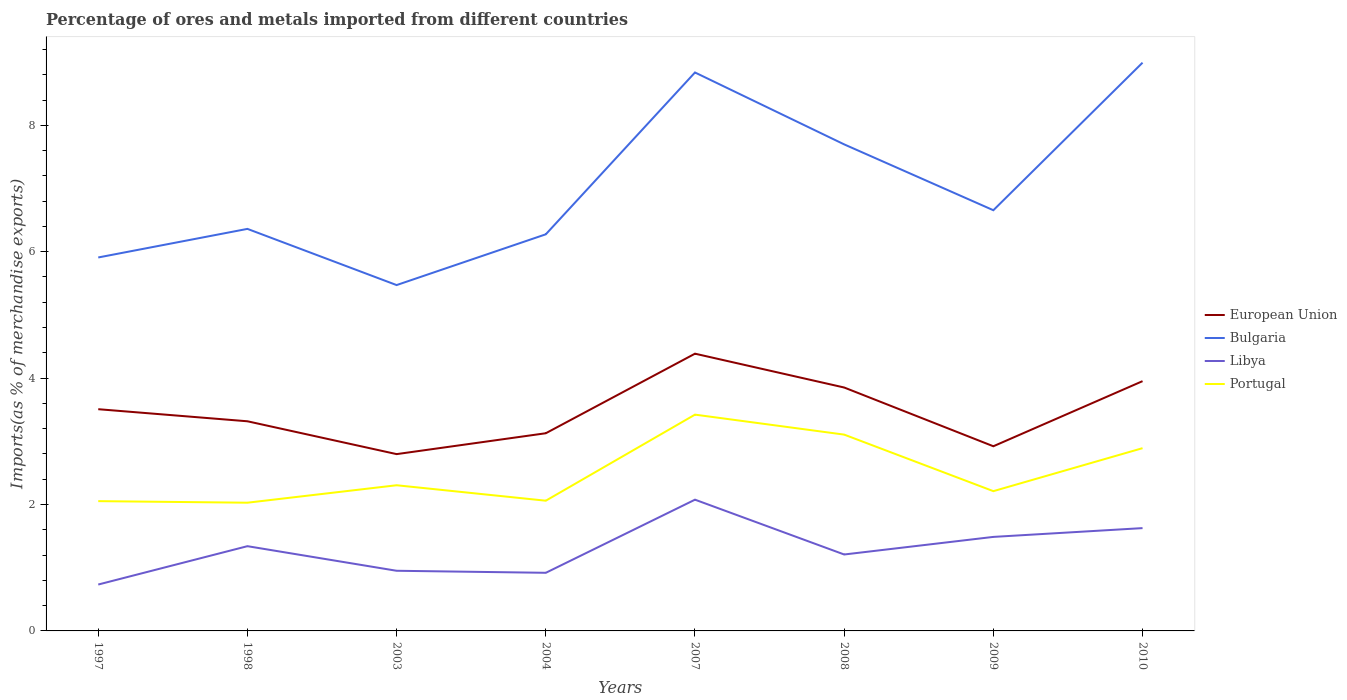Is the number of lines equal to the number of legend labels?
Offer a very short reply. Yes. Across all years, what is the maximum percentage of imports to different countries in Bulgaria?
Ensure brevity in your answer.  5.47. What is the total percentage of imports to different countries in European Union in the graph?
Make the answer very short. -1.59. What is the difference between the highest and the second highest percentage of imports to different countries in Libya?
Give a very brief answer. 1.34. Is the percentage of imports to different countries in Libya strictly greater than the percentage of imports to different countries in Portugal over the years?
Keep it short and to the point. Yes. Are the values on the major ticks of Y-axis written in scientific E-notation?
Provide a short and direct response. No. Does the graph contain any zero values?
Offer a very short reply. No. Where does the legend appear in the graph?
Your response must be concise. Center right. How many legend labels are there?
Make the answer very short. 4. What is the title of the graph?
Keep it short and to the point. Percentage of ores and metals imported from different countries. What is the label or title of the Y-axis?
Make the answer very short. Imports(as % of merchandise exports). What is the Imports(as % of merchandise exports) of European Union in 1997?
Your answer should be compact. 3.51. What is the Imports(as % of merchandise exports) in Bulgaria in 1997?
Your answer should be compact. 5.91. What is the Imports(as % of merchandise exports) in Libya in 1997?
Offer a very short reply. 0.73. What is the Imports(as % of merchandise exports) in Portugal in 1997?
Ensure brevity in your answer.  2.05. What is the Imports(as % of merchandise exports) in European Union in 1998?
Offer a terse response. 3.32. What is the Imports(as % of merchandise exports) in Bulgaria in 1998?
Your answer should be very brief. 6.36. What is the Imports(as % of merchandise exports) of Libya in 1998?
Make the answer very short. 1.34. What is the Imports(as % of merchandise exports) of Portugal in 1998?
Your answer should be very brief. 2.03. What is the Imports(as % of merchandise exports) in European Union in 2003?
Offer a very short reply. 2.8. What is the Imports(as % of merchandise exports) in Bulgaria in 2003?
Your response must be concise. 5.47. What is the Imports(as % of merchandise exports) of Libya in 2003?
Your answer should be very brief. 0.95. What is the Imports(as % of merchandise exports) of Portugal in 2003?
Offer a terse response. 2.3. What is the Imports(as % of merchandise exports) of European Union in 2004?
Your response must be concise. 3.13. What is the Imports(as % of merchandise exports) in Bulgaria in 2004?
Your answer should be very brief. 6.28. What is the Imports(as % of merchandise exports) in Libya in 2004?
Provide a short and direct response. 0.92. What is the Imports(as % of merchandise exports) of Portugal in 2004?
Your answer should be compact. 2.06. What is the Imports(as % of merchandise exports) in European Union in 2007?
Give a very brief answer. 4.39. What is the Imports(as % of merchandise exports) in Bulgaria in 2007?
Give a very brief answer. 8.84. What is the Imports(as % of merchandise exports) of Libya in 2007?
Your answer should be compact. 2.08. What is the Imports(as % of merchandise exports) in Portugal in 2007?
Provide a succinct answer. 3.42. What is the Imports(as % of merchandise exports) in European Union in 2008?
Your answer should be very brief. 3.85. What is the Imports(as % of merchandise exports) of Bulgaria in 2008?
Offer a very short reply. 7.7. What is the Imports(as % of merchandise exports) in Libya in 2008?
Your answer should be very brief. 1.21. What is the Imports(as % of merchandise exports) in Portugal in 2008?
Ensure brevity in your answer.  3.11. What is the Imports(as % of merchandise exports) in European Union in 2009?
Make the answer very short. 2.92. What is the Imports(as % of merchandise exports) of Bulgaria in 2009?
Your answer should be very brief. 6.66. What is the Imports(as % of merchandise exports) in Libya in 2009?
Offer a terse response. 1.49. What is the Imports(as % of merchandise exports) of Portugal in 2009?
Provide a short and direct response. 2.21. What is the Imports(as % of merchandise exports) of European Union in 2010?
Give a very brief answer. 3.95. What is the Imports(as % of merchandise exports) of Bulgaria in 2010?
Ensure brevity in your answer.  8.99. What is the Imports(as % of merchandise exports) of Libya in 2010?
Your answer should be very brief. 1.63. What is the Imports(as % of merchandise exports) in Portugal in 2010?
Give a very brief answer. 2.89. Across all years, what is the maximum Imports(as % of merchandise exports) in European Union?
Your response must be concise. 4.39. Across all years, what is the maximum Imports(as % of merchandise exports) in Bulgaria?
Your answer should be very brief. 8.99. Across all years, what is the maximum Imports(as % of merchandise exports) in Libya?
Provide a short and direct response. 2.08. Across all years, what is the maximum Imports(as % of merchandise exports) in Portugal?
Provide a succinct answer. 3.42. Across all years, what is the minimum Imports(as % of merchandise exports) of European Union?
Ensure brevity in your answer.  2.8. Across all years, what is the minimum Imports(as % of merchandise exports) of Bulgaria?
Give a very brief answer. 5.47. Across all years, what is the minimum Imports(as % of merchandise exports) of Libya?
Offer a terse response. 0.73. Across all years, what is the minimum Imports(as % of merchandise exports) of Portugal?
Your answer should be very brief. 2.03. What is the total Imports(as % of merchandise exports) in European Union in the graph?
Provide a short and direct response. 27.86. What is the total Imports(as % of merchandise exports) in Bulgaria in the graph?
Your answer should be very brief. 56.2. What is the total Imports(as % of merchandise exports) of Libya in the graph?
Offer a very short reply. 10.35. What is the total Imports(as % of merchandise exports) of Portugal in the graph?
Make the answer very short. 20.08. What is the difference between the Imports(as % of merchandise exports) of European Union in 1997 and that in 1998?
Offer a terse response. 0.19. What is the difference between the Imports(as % of merchandise exports) of Bulgaria in 1997 and that in 1998?
Ensure brevity in your answer.  -0.45. What is the difference between the Imports(as % of merchandise exports) of Libya in 1997 and that in 1998?
Provide a succinct answer. -0.61. What is the difference between the Imports(as % of merchandise exports) in Portugal in 1997 and that in 1998?
Keep it short and to the point. 0.02. What is the difference between the Imports(as % of merchandise exports) in European Union in 1997 and that in 2003?
Your answer should be very brief. 0.71. What is the difference between the Imports(as % of merchandise exports) of Bulgaria in 1997 and that in 2003?
Offer a terse response. 0.44. What is the difference between the Imports(as % of merchandise exports) in Libya in 1997 and that in 2003?
Ensure brevity in your answer.  -0.22. What is the difference between the Imports(as % of merchandise exports) of Portugal in 1997 and that in 2003?
Provide a succinct answer. -0.25. What is the difference between the Imports(as % of merchandise exports) of European Union in 1997 and that in 2004?
Give a very brief answer. 0.38. What is the difference between the Imports(as % of merchandise exports) in Bulgaria in 1997 and that in 2004?
Keep it short and to the point. -0.37. What is the difference between the Imports(as % of merchandise exports) of Libya in 1997 and that in 2004?
Offer a terse response. -0.19. What is the difference between the Imports(as % of merchandise exports) of Portugal in 1997 and that in 2004?
Make the answer very short. -0.01. What is the difference between the Imports(as % of merchandise exports) of European Union in 1997 and that in 2007?
Provide a succinct answer. -0.88. What is the difference between the Imports(as % of merchandise exports) of Bulgaria in 1997 and that in 2007?
Provide a succinct answer. -2.93. What is the difference between the Imports(as % of merchandise exports) in Libya in 1997 and that in 2007?
Provide a short and direct response. -1.34. What is the difference between the Imports(as % of merchandise exports) in Portugal in 1997 and that in 2007?
Keep it short and to the point. -1.37. What is the difference between the Imports(as % of merchandise exports) in European Union in 1997 and that in 2008?
Your answer should be very brief. -0.34. What is the difference between the Imports(as % of merchandise exports) of Bulgaria in 1997 and that in 2008?
Your answer should be very brief. -1.79. What is the difference between the Imports(as % of merchandise exports) of Libya in 1997 and that in 2008?
Ensure brevity in your answer.  -0.48. What is the difference between the Imports(as % of merchandise exports) in Portugal in 1997 and that in 2008?
Your response must be concise. -1.05. What is the difference between the Imports(as % of merchandise exports) in European Union in 1997 and that in 2009?
Your answer should be compact. 0.59. What is the difference between the Imports(as % of merchandise exports) of Bulgaria in 1997 and that in 2009?
Make the answer very short. -0.75. What is the difference between the Imports(as % of merchandise exports) of Libya in 1997 and that in 2009?
Offer a very short reply. -0.75. What is the difference between the Imports(as % of merchandise exports) in Portugal in 1997 and that in 2009?
Give a very brief answer. -0.16. What is the difference between the Imports(as % of merchandise exports) of European Union in 1997 and that in 2010?
Provide a succinct answer. -0.44. What is the difference between the Imports(as % of merchandise exports) in Bulgaria in 1997 and that in 2010?
Provide a short and direct response. -3.08. What is the difference between the Imports(as % of merchandise exports) of Libya in 1997 and that in 2010?
Your answer should be compact. -0.89. What is the difference between the Imports(as % of merchandise exports) of Portugal in 1997 and that in 2010?
Your answer should be very brief. -0.84. What is the difference between the Imports(as % of merchandise exports) of European Union in 1998 and that in 2003?
Your answer should be very brief. 0.52. What is the difference between the Imports(as % of merchandise exports) in Bulgaria in 1998 and that in 2003?
Your answer should be very brief. 0.89. What is the difference between the Imports(as % of merchandise exports) of Libya in 1998 and that in 2003?
Your response must be concise. 0.39. What is the difference between the Imports(as % of merchandise exports) of Portugal in 1998 and that in 2003?
Provide a short and direct response. -0.28. What is the difference between the Imports(as % of merchandise exports) in European Union in 1998 and that in 2004?
Make the answer very short. 0.19. What is the difference between the Imports(as % of merchandise exports) in Bulgaria in 1998 and that in 2004?
Give a very brief answer. 0.09. What is the difference between the Imports(as % of merchandise exports) in Libya in 1998 and that in 2004?
Give a very brief answer. 0.42. What is the difference between the Imports(as % of merchandise exports) in Portugal in 1998 and that in 2004?
Ensure brevity in your answer.  -0.03. What is the difference between the Imports(as % of merchandise exports) of European Union in 1998 and that in 2007?
Offer a very short reply. -1.07. What is the difference between the Imports(as % of merchandise exports) of Bulgaria in 1998 and that in 2007?
Give a very brief answer. -2.47. What is the difference between the Imports(as % of merchandise exports) in Libya in 1998 and that in 2007?
Give a very brief answer. -0.74. What is the difference between the Imports(as % of merchandise exports) in Portugal in 1998 and that in 2007?
Ensure brevity in your answer.  -1.39. What is the difference between the Imports(as % of merchandise exports) of European Union in 1998 and that in 2008?
Your answer should be compact. -0.53. What is the difference between the Imports(as % of merchandise exports) in Bulgaria in 1998 and that in 2008?
Offer a terse response. -1.34. What is the difference between the Imports(as % of merchandise exports) in Libya in 1998 and that in 2008?
Give a very brief answer. 0.13. What is the difference between the Imports(as % of merchandise exports) in Portugal in 1998 and that in 2008?
Your answer should be very brief. -1.08. What is the difference between the Imports(as % of merchandise exports) of European Union in 1998 and that in 2009?
Your response must be concise. 0.4. What is the difference between the Imports(as % of merchandise exports) in Bulgaria in 1998 and that in 2009?
Offer a terse response. -0.3. What is the difference between the Imports(as % of merchandise exports) in Libya in 1998 and that in 2009?
Your answer should be very brief. -0.15. What is the difference between the Imports(as % of merchandise exports) of Portugal in 1998 and that in 2009?
Make the answer very short. -0.18. What is the difference between the Imports(as % of merchandise exports) in European Union in 1998 and that in 2010?
Make the answer very short. -0.63. What is the difference between the Imports(as % of merchandise exports) in Bulgaria in 1998 and that in 2010?
Your answer should be compact. -2.63. What is the difference between the Imports(as % of merchandise exports) of Libya in 1998 and that in 2010?
Your answer should be very brief. -0.29. What is the difference between the Imports(as % of merchandise exports) of Portugal in 1998 and that in 2010?
Make the answer very short. -0.86. What is the difference between the Imports(as % of merchandise exports) in European Union in 2003 and that in 2004?
Offer a very short reply. -0.33. What is the difference between the Imports(as % of merchandise exports) of Bulgaria in 2003 and that in 2004?
Ensure brevity in your answer.  -0.8. What is the difference between the Imports(as % of merchandise exports) of Libya in 2003 and that in 2004?
Your answer should be very brief. 0.03. What is the difference between the Imports(as % of merchandise exports) in Portugal in 2003 and that in 2004?
Your response must be concise. 0.24. What is the difference between the Imports(as % of merchandise exports) of European Union in 2003 and that in 2007?
Provide a succinct answer. -1.59. What is the difference between the Imports(as % of merchandise exports) of Bulgaria in 2003 and that in 2007?
Your response must be concise. -3.36. What is the difference between the Imports(as % of merchandise exports) in Libya in 2003 and that in 2007?
Provide a short and direct response. -1.12. What is the difference between the Imports(as % of merchandise exports) in Portugal in 2003 and that in 2007?
Give a very brief answer. -1.12. What is the difference between the Imports(as % of merchandise exports) in European Union in 2003 and that in 2008?
Keep it short and to the point. -1.05. What is the difference between the Imports(as % of merchandise exports) of Bulgaria in 2003 and that in 2008?
Keep it short and to the point. -2.23. What is the difference between the Imports(as % of merchandise exports) in Libya in 2003 and that in 2008?
Offer a terse response. -0.26. What is the difference between the Imports(as % of merchandise exports) of Portugal in 2003 and that in 2008?
Your answer should be very brief. -0.8. What is the difference between the Imports(as % of merchandise exports) in European Union in 2003 and that in 2009?
Keep it short and to the point. -0.12. What is the difference between the Imports(as % of merchandise exports) of Bulgaria in 2003 and that in 2009?
Make the answer very short. -1.18. What is the difference between the Imports(as % of merchandise exports) of Libya in 2003 and that in 2009?
Your answer should be compact. -0.54. What is the difference between the Imports(as % of merchandise exports) in Portugal in 2003 and that in 2009?
Your response must be concise. 0.09. What is the difference between the Imports(as % of merchandise exports) of European Union in 2003 and that in 2010?
Offer a terse response. -1.15. What is the difference between the Imports(as % of merchandise exports) of Bulgaria in 2003 and that in 2010?
Offer a terse response. -3.52. What is the difference between the Imports(as % of merchandise exports) of Libya in 2003 and that in 2010?
Ensure brevity in your answer.  -0.68. What is the difference between the Imports(as % of merchandise exports) in Portugal in 2003 and that in 2010?
Provide a short and direct response. -0.59. What is the difference between the Imports(as % of merchandise exports) in European Union in 2004 and that in 2007?
Ensure brevity in your answer.  -1.26. What is the difference between the Imports(as % of merchandise exports) in Bulgaria in 2004 and that in 2007?
Your answer should be compact. -2.56. What is the difference between the Imports(as % of merchandise exports) in Libya in 2004 and that in 2007?
Your response must be concise. -1.16. What is the difference between the Imports(as % of merchandise exports) in Portugal in 2004 and that in 2007?
Make the answer very short. -1.36. What is the difference between the Imports(as % of merchandise exports) in European Union in 2004 and that in 2008?
Your answer should be compact. -0.72. What is the difference between the Imports(as % of merchandise exports) of Bulgaria in 2004 and that in 2008?
Your answer should be compact. -1.42. What is the difference between the Imports(as % of merchandise exports) of Libya in 2004 and that in 2008?
Keep it short and to the point. -0.29. What is the difference between the Imports(as % of merchandise exports) of Portugal in 2004 and that in 2008?
Provide a short and direct response. -1.05. What is the difference between the Imports(as % of merchandise exports) of European Union in 2004 and that in 2009?
Offer a very short reply. 0.21. What is the difference between the Imports(as % of merchandise exports) in Bulgaria in 2004 and that in 2009?
Your response must be concise. -0.38. What is the difference between the Imports(as % of merchandise exports) in Libya in 2004 and that in 2009?
Provide a succinct answer. -0.57. What is the difference between the Imports(as % of merchandise exports) in Portugal in 2004 and that in 2009?
Offer a terse response. -0.15. What is the difference between the Imports(as % of merchandise exports) in European Union in 2004 and that in 2010?
Give a very brief answer. -0.82. What is the difference between the Imports(as % of merchandise exports) in Bulgaria in 2004 and that in 2010?
Keep it short and to the point. -2.72. What is the difference between the Imports(as % of merchandise exports) in Libya in 2004 and that in 2010?
Make the answer very short. -0.71. What is the difference between the Imports(as % of merchandise exports) in Portugal in 2004 and that in 2010?
Give a very brief answer. -0.83. What is the difference between the Imports(as % of merchandise exports) in European Union in 2007 and that in 2008?
Your answer should be compact. 0.54. What is the difference between the Imports(as % of merchandise exports) of Bulgaria in 2007 and that in 2008?
Give a very brief answer. 1.14. What is the difference between the Imports(as % of merchandise exports) of Libya in 2007 and that in 2008?
Provide a short and direct response. 0.87. What is the difference between the Imports(as % of merchandise exports) in Portugal in 2007 and that in 2008?
Your answer should be compact. 0.32. What is the difference between the Imports(as % of merchandise exports) in European Union in 2007 and that in 2009?
Ensure brevity in your answer.  1.46. What is the difference between the Imports(as % of merchandise exports) of Bulgaria in 2007 and that in 2009?
Keep it short and to the point. 2.18. What is the difference between the Imports(as % of merchandise exports) in Libya in 2007 and that in 2009?
Your answer should be very brief. 0.59. What is the difference between the Imports(as % of merchandise exports) in Portugal in 2007 and that in 2009?
Ensure brevity in your answer.  1.21. What is the difference between the Imports(as % of merchandise exports) in European Union in 2007 and that in 2010?
Your answer should be very brief. 0.43. What is the difference between the Imports(as % of merchandise exports) in Bulgaria in 2007 and that in 2010?
Provide a short and direct response. -0.16. What is the difference between the Imports(as % of merchandise exports) in Libya in 2007 and that in 2010?
Your answer should be very brief. 0.45. What is the difference between the Imports(as % of merchandise exports) in Portugal in 2007 and that in 2010?
Your answer should be compact. 0.53. What is the difference between the Imports(as % of merchandise exports) in European Union in 2008 and that in 2009?
Ensure brevity in your answer.  0.93. What is the difference between the Imports(as % of merchandise exports) in Bulgaria in 2008 and that in 2009?
Your answer should be compact. 1.04. What is the difference between the Imports(as % of merchandise exports) in Libya in 2008 and that in 2009?
Provide a succinct answer. -0.28. What is the difference between the Imports(as % of merchandise exports) of Portugal in 2008 and that in 2009?
Keep it short and to the point. 0.89. What is the difference between the Imports(as % of merchandise exports) in European Union in 2008 and that in 2010?
Provide a short and direct response. -0.1. What is the difference between the Imports(as % of merchandise exports) of Bulgaria in 2008 and that in 2010?
Your answer should be compact. -1.29. What is the difference between the Imports(as % of merchandise exports) in Libya in 2008 and that in 2010?
Your response must be concise. -0.42. What is the difference between the Imports(as % of merchandise exports) of Portugal in 2008 and that in 2010?
Your answer should be very brief. 0.21. What is the difference between the Imports(as % of merchandise exports) of European Union in 2009 and that in 2010?
Offer a terse response. -1.03. What is the difference between the Imports(as % of merchandise exports) in Bulgaria in 2009 and that in 2010?
Provide a short and direct response. -2.33. What is the difference between the Imports(as % of merchandise exports) of Libya in 2009 and that in 2010?
Ensure brevity in your answer.  -0.14. What is the difference between the Imports(as % of merchandise exports) in Portugal in 2009 and that in 2010?
Keep it short and to the point. -0.68. What is the difference between the Imports(as % of merchandise exports) in European Union in 1997 and the Imports(as % of merchandise exports) in Bulgaria in 1998?
Provide a succinct answer. -2.85. What is the difference between the Imports(as % of merchandise exports) in European Union in 1997 and the Imports(as % of merchandise exports) in Libya in 1998?
Ensure brevity in your answer.  2.17. What is the difference between the Imports(as % of merchandise exports) in European Union in 1997 and the Imports(as % of merchandise exports) in Portugal in 1998?
Provide a succinct answer. 1.48. What is the difference between the Imports(as % of merchandise exports) of Bulgaria in 1997 and the Imports(as % of merchandise exports) of Libya in 1998?
Give a very brief answer. 4.57. What is the difference between the Imports(as % of merchandise exports) in Bulgaria in 1997 and the Imports(as % of merchandise exports) in Portugal in 1998?
Make the answer very short. 3.88. What is the difference between the Imports(as % of merchandise exports) in Libya in 1997 and the Imports(as % of merchandise exports) in Portugal in 1998?
Your answer should be very brief. -1.29. What is the difference between the Imports(as % of merchandise exports) of European Union in 1997 and the Imports(as % of merchandise exports) of Bulgaria in 2003?
Offer a very short reply. -1.96. What is the difference between the Imports(as % of merchandise exports) of European Union in 1997 and the Imports(as % of merchandise exports) of Libya in 2003?
Your answer should be compact. 2.56. What is the difference between the Imports(as % of merchandise exports) of European Union in 1997 and the Imports(as % of merchandise exports) of Portugal in 2003?
Make the answer very short. 1.2. What is the difference between the Imports(as % of merchandise exports) in Bulgaria in 1997 and the Imports(as % of merchandise exports) in Libya in 2003?
Ensure brevity in your answer.  4.96. What is the difference between the Imports(as % of merchandise exports) in Bulgaria in 1997 and the Imports(as % of merchandise exports) in Portugal in 2003?
Ensure brevity in your answer.  3.6. What is the difference between the Imports(as % of merchandise exports) in Libya in 1997 and the Imports(as % of merchandise exports) in Portugal in 2003?
Provide a succinct answer. -1.57. What is the difference between the Imports(as % of merchandise exports) in European Union in 1997 and the Imports(as % of merchandise exports) in Bulgaria in 2004?
Provide a succinct answer. -2.77. What is the difference between the Imports(as % of merchandise exports) in European Union in 1997 and the Imports(as % of merchandise exports) in Libya in 2004?
Make the answer very short. 2.59. What is the difference between the Imports(as % of merchandise exports) in European Union in 1997 and the Imports(as % of merchandise exports) in Portugal in 2004?
Provide a succinct answer. 1.45. What is the difference between the Imports(as % of merchandise exports) in Bulgaria in 1997 and the Imports(as % of merchandise exports) in Libya in 2004?
Offer a terse response. 4.99. What is the difference between the Imports(as % of merchandise exports) in Bulgaria in 1997 and the Imports(as % of merchandise exports) in Portugal in 2004?
Your answer should be very brief. 3.85. What is the difference between the Imports(as % of merchandise exports) of Libya in 1997 and the Imports(as % of merchandise exports) of Portugal in 2004?
Provide a succinct answer. -1.33. What is the difference between the Imports(as % of merchandise exports) in European Union in 1997 and the Imports(as % of merchandise exports) in Bulgaria in 2007?
Your answer should be compact. -5.33. What is the difference between the Imports(as % of merchandise exports) of European Union in 1997 and the Imports(as % of merchandise exports) of Libya in 2007?
Offer a very short reply. 1.43. What is the difference between the Imports(as % of merchandise exports) of European Union in 1997 and the Imports(as % of merchandise exports) of Portugal in 2007?
Ensure brevity in your answer.  0.09. What is the difference between the Imports(as % of merchandise exports) of Bulgaria in 1997 and the Imports(as % of merchandise exports) of Libya in 2007?
Your response must be concise. 3.83. What is the difference between the Imports(as % of merchandise exports) of Bulgaria in 1997 and the Imports(as % of merchandise exports) of Portugal in 2007?
Provide a short and direct response. 2.49. What is the difference between the Imports(as % of merchandise exports) of Libya in 1997 and the Imports(as % of merchandise exports) of Portugal in 2007?
Your answer should be very brief. -2.69. What is the difference between the Imports(as % of merchandise exports) in European Union in 1997 and the Imports(as % of merchandise exports) in Bulgaria in 2008?
Keep it short and to the point. -4.19. What is the difference between the Imports(as % of merchandise exports) of European Union in 1997 and the Imports(as % of merchandise exports) of Libya in 2008?
Your answer should be compact. 2.3. What is the difference between the Imports(as % of merchandise exports) of European Union in 1997 and the Imports(as % of merchandise exports) of Portugal in 2008?
Your answer should be compact. 0.4. What is the difference between the Imports(as % of merchandise exports) of Bulgaria in 1997 and the Imports(as % of merchandise exports) of Libya in 2008?
Your answer should be compact. 4.7. What is the difference between the Imports(as % of merchandise exports) of Bulgaria in 1997 and the Imports(as % of merchandise exports) of Portugal in 2008?
Provide a succinct answer. 2.8. What is the difference between the Imports(as % of merchandise exports) of Libya in 1997 and the Imports(as % of merchandise exports) of Portugal in 2008?
Offer a terse response. -2.37. What is the difference between the Imports(as % of merchandise exports) of European Union in 1997 and the Imports(as % of merchandise exports) of Bulgaria in 2009?
Your answer should be compact. -3.15. What is the difference between the Imports(as % of merchandise exports) in European Union in 1997 and the Imports(as % of merchandise exports) in Libya in 2009?
Make the answer very short. 2.02. What is the difference between the Imports(as % of merchandise exports) of European Union in 1997 and the Imports(as % of merchandise exports) of Portugal in 2009?
Keep it short and to the point. 1.3. What is the difference between the Imports(as % of merchandise exports) of Bulgaria in 1997 and the Imports(as % of merchandise exports) of Libya in 2009?
Offer a very short reply. 4.42. What is the difference between the Imports(as % of merchandise exports) of Bulgaria in 1997 and the Imports(as % of merchandise exports) of Portugal in 2009?
Give a very brief answer. 3.7. What is the difference between the Imports(as % of merchandise exports) of Libya in 1997 and the Imports(as % of merchandise exports) of Portugal in 2009?
Offer a terse response. -1.48. What is the difference between the Imports(as % of merchandise exports) in European Union in 1997 and the Imports(as % of merchandise exports) in Bulgaria in 2010?
Your answer should be compact. -5.48. What is the difference between the Imports(as % of merchandise exports) of European Union in 1997 and the Imports(as % of merchandise exports) of Libya in 2010?
Provide a short and direct response. 1.88. What is the difference between the Imports(as % of merchandise exports) of European Union in 1997 and the Imports(as % of merchandise exports) of Portugal in 2010?
Your answer should be very brief. 0.62. What is the difference between the Imports(as % of merchandise exports) of Bulgaria in 1997 and the Imports(as % of merchandise exports) of Libya in 2010?
Provide a short and direct response. 4.28. What is the difference between the Imports(as % of merchandise exports) of Bulgaria in 1997 and the Imports(as % of merchandise exports) of Portugal in 2010?
Provide a succinct answer. 3.02. What is the difference between the Imports(as % of merchandise exports) in Libya in 1997 and the Imports(as % of merchandise exports) in Portugal in 2010?
Your response must be concise. -2.16. What is the difference between the Imports(as % of merchandise exports) of European Union in 1998 and the Imports(as % of merchandise exports) of Bulgaria in 2003?
Provide a succinct answer. -2.15. What is the difference between the Imports(as % of merchandise exports) in European Union in 1998 and the Imports(as % of merchandise exports) in Libya in 2003?
Give a very brief answer. 2.37. What is the difference between the Imports(as % of merchandise exports) of European Union in 1998 and the Imports(as % of merchandise exports) of Portugal in 2003?
Provide a short and direct response. 1.01. What is the difference between the Imports(as % of merchandise exports) of Bulgaria in 1998 and the Imports(as % of merchandise exports) of Libya in 2003?
Your answer should be compact. 5.41. What is the difference between the Imports(as % of merchandise exports) in Bulgaria in 1998 and the Imports(as % of merchandise exports) in Portugal in 2003?
Ensure brevity in your answer.  4.06. What is the difference between the Imports(as % of merchandise exports) of Libya in 1998 and the Imports(as % of merchandise exports) of Portugal in 2003?
Your answer should be compact. -0.96. What is the difference between the Imports(as % of merchandise exports) of European Union in 1998 and the Imports(as % of merchandise exports) of Bulgaria in 2004?
Provide a short and direct response. -2.96. What is the difference between the Imports(as % of merchandise exports) in European Union in 1998 and the Imports(as % of merchandise exports) in Libya in 2004?
Offer a very short reply. 2.4. What is the difference between the Imports(as % of merchandise exports) of European Union in 1998 and the Imports(as % of merchandise exports) of Portugal in 2004?
Provide a short and direct response. 1.26. What is the difference between the Imports(as % of merchandise exports) in Bulgaria in 1998 and the Imports(as % of merchandise exports) in Libya in 2004?
Provide a short and direct response. 5.44. What is the difference between the Imports(as % of merchandise exports) of Bulgaria in 1998 and the Imports(as % of merchandise exports) of Portugal in 2004?
Keep it short and to the point. 4.3. What is the difference between the Imports(as % of merchandise exports) of Libya in 1998 and the Imports(as % of merchandise exports) of Portugal in 2004?
Provide a succinct answer. -0.72. What is the difference between the Imports(as % of merchandise exports) of European Union in 1998 and the Imports(as % of merchandise exports) of Bulgaria in 2007?
Give a very brief answer. -5.52. What is the difference between the Imports(as % of merchandise exports) of European Union in 1998 and the Imports(as % of merchandise exports) of Libya in 2007?
Keep it short and to the point. 1.24. What is the difference between the Imports(as % of merchandise exports) in European Union in 1998 and the Imports(as % of merchandise exports) in Portugal in 2007?
Your answer should be compact. -0.11. What is the difference between the Imports(as % of merchandise exports) of Bulgaria in 1998 and the Imports(as % of merchandise exports) of Libya in 2007?
Your response must be concise. 4.28. What is the difference between the Imports(as % of merchandise exports) of Bulgaria in 1998 and the Imports(as % of merchandise exports) of Portugal in 2007?
Your response must be concise. 2.94. What is the difference between the Imports(as % of merchandise exports) in Libya in 1998 and the Imports(as % of merchandise exports) in Portugal in 2007?
Offer a terse response. -2.08. What is the difference between the Imports(as % of merchandise exports) in European Union in 1998 and the Imports(as % of merchandise exports) in Bulgaria in 2008?
Make the answer very short. -4.38. What is the difference between the Imports(as % of merchandise exports) of European Union in 1998 and the Imports(as % of merchandise exports) of Libya in 2008?
Give a very brief answer. 2.11. What is the difference between the Imports(as % of merchandise exports) of European Union in 1998 and the Imports(as % of merchandise exports) of Portugal in 2008?
Offer a very short reply. 0.21. What is the difference between the Imports(as % of merchandise exports) in Bulgaria in 1998 and the Imports(as % of merchandise exports) in Libya in 2008?
Make the answer very short. 5.15. What is the difference between the Imports(as % of merchandise exports) in Bulgaria in 1998 and the Imports(as % of merchandise exports) in Portugal in 2008?
Your response must be concise. 3.25. What is the difference between the Imports(as % of merchandise exports) of Libya in 1998 and the Imports(as % of merchandise exports) of Portugal in 2008?
Your response must be concise. -1.77. What is the difference between the Imports(as % of merchandise exports) in European Union in 1998 and the Imports(as % of merchandise exports) in Bulgaria in 2009?
Keep it short and to the point. -3.34. What is the difference between the Imports(as % of merchandise exports) in European Union in 1998 and the Imports(as % of merchandise exports) in Libya in 2009?
Give a very brief answer. 1.83. What is the difference between the Imports(as % of merchandise exports) in European Union in 1998 and the Imports(as % of merchandise exports) in Portugal in 2009?
Your answer should be compact. 1.11. What is the difference between the Imports(as % of merchandise exports) of Bulgaria in 1998 and the Imports(as % of merchandise exports) of Libya in 2009?
Provide a short and direct response. 4.87. What is the difference between the Imports(as % of merchandise exports) in Bulgaria in 1998 and the Imports(as % of merchandise exports) in Portugal in 2009?
Your answer should be very brief. 4.15. What is the difference between the Imports(as % of merchandise exports) in Libya in 1998 and the Imports(as % of merchandise exports) in Portugal in 2009?
Ensure brevity in your answer.  -0.87. What is the difference between the Imports(as % of merchandise exports) in European Union in 1998 and the Imports(as % of merchandise exports) in Bulgaria in 2010?
Provide a succinct answer. -5.67. What is the difference between the Imports(as % of merchandise exports) in European Union in 1998 and the Imports(as % of merchandise exports) in Libya in 2010?
Offer a terse response. 1.69. What is the difference between the Imports(as % of merchandise exports) of European Union in 1998 and the Imports(as % of merchandise exports) of Portugal in 2010?
Provide a succinct answer. 0.43. What is the difference between the Imports(as % of merchandise exports) in Bulgaria in 1998 and the Imports(as % of merchandise exports) in Libya in 2010?
Your answer should be very brief. 4.73. What is the difference between the Imports(as % of merchandise exports) of Bulgaria in 1998 and the Imports(as % of merchandise exports) of Portugal in 2010?
Offer a terse response. 3.47. What is the difference between the Imports(as % of merchandise exports) of Libya in 1998 and the Imports(as % of merchandise exports) of Portugal in 2010?
Offer a very short reply. -1.55. What is the difference between the Imports(as % of merchandise exports) of European Union in 2003 and the Imports(as % of merchandise exports) of Bulgaria in 2004?
Your response must be concise. -3.48. What is the difference between the Imports(as % of merchandise exports) of European Union in 2003 and the Imports(as % of merchandise exports) of Libya in 2004?
Ensure brevity in your answer.  1.88. What is the difference between the Imports(as % of merchandise exports) in European Union in 2003 and the Imports(as % of merchandise exports) in Portugal in 2004?
Offer a terse response. 0.74. What is the difference between the Imports(as % of merchandise exports) in Bulgaria in 2003 and the Imports(as % of merchandise exports) in Libya in 2004?
Your answer should be compact. 4.55. What is the difference between the Imports(as % of merchandise exports) in Bulgaria in 2003 and the Imports(as % of merchandise exports) in Portugal in 2004?
Make the answer very short. 3.41. What is the difference between the Imports(as % of merchandise exports) in Libya in 2003 and the Imports(as % of merchandise exports) in Portugal in 2004?
Provide a short and direct response. -1.11. What is the difference between the Imports(as % of merchandise exports) of European Union in 2003 and the Imports(as % of merchandise exports) of Bulgaria in 2007?
Provide a short and direct response. -6.04. What is the difference between the Imports(as % of merchandise exports) in European Union in 2003 and the Imports(as % of merchandise exports) in Libya in 2007?
Offer a very short reply. 0.72. What is the difference between the Imports(as % of merchandise exports) of European Union in 2003 and the Imports(as % of merchandise exports) of Portugal in 2007?
Your answer should be very brief. -0.62. What is the difference between the Imports(as % of merchandise exports) of Bulgaria in 2003 and the Imports(as % of merchandise exports) of Libya in 2007?
Ensure brevity in your answer.  3.4. What is the difference between the Imports(as % of merchandise exports) of Bulgaria in 2003 and the Imports(as % of merchandise exports) of Portugal in 2007?
Provide a short and direct response. 2.05. What is the difference between the Imports(as % of merchandise exports) in Libya in 2003 and the Imports(as % of merchandise exports) in Portugal in 2007?
Provide a succinct answer. -2.47. What is the difference between the Imports(as % of merchandise exports) in European Union in 2003 and the Imports(as % of merchandise exports) in Bulgaria in 2008?
Make the answer very short. -4.9. What is the difference between the Imports(as % of merchandise exports) of European Union in 2003 and the Imports(as % of merchandise exports) of Libya in 2008?
Keep it short and to the point. 1.59. What is the difference between the Imports(as % of merchandise exports) of European Union in 2003 and the Imports(as % of merchandise exports) of Portugal in 2008?
Your response must be concise. -0.31. What is the difference between the Imports(as % of merchandise exports) of Bulgaria in 2003 and the Imports(as % of merchandise exports) of Libya in 2008?
Provide a succinct answer. 4.26. What is the difference between the Imports(as % of merchandise exports) of Bulgaria in 2003 and the Imports(as % of merchandise exports) of Portugal in 2008?
Keep it short and to the point. 2.37. What is the difference between the Imports(as % of merchandise exports) in Libya in 2003 and the Imports(as % of merchandise exports) in Portugal in 2008?
Make the answer very short. -2.15. What is the difference between the Imports(as % of merchandise exports) in European Union in 2003 and the Imports(as % of merchandise exports) in Bulgaria in 2009?
Ensure brevity in your answer.  -3.86. What is the difference between the Imports(as % of merchandise exports) in European Union in 2003 and the Imports(as % of merchandise exports) in Libya in 2009?
Offer a terse response. 1.31. What is the difference between the Imports(as % of merchandise exports) of European Union in 2003 and the Imports(as % of merchandise exports) of Portugal in 2009?
Ensure brevity in your answer.  0.59. What is the difference between the Imports(as % of merchandise exports) of Bulgaria in 2003 and the Imports(as % of merchandise exports) of Libya in 2009?
Your answer should be compact. 3.98. What is the difference between the Imports(as % of merchandise exports) in Bulgaria in 2003 and the Imports(as % of merchandise exports) in Portugal in 2009?
Offer a very short reply. 3.26. What is the difference between the Imports(as % of merchandise exports) of Libya in 2003 and the Imports(as % of merchandise exports) of Portugal in 2009?
Provide a short and direct response. -1.26. What is the difference between the Imports(as % of merchandise exports) in European Union in 2003 and the Imports(as % of merchandise exports) in Bulgaria in 2010?
Your answer should be very brief. -6.19. What is the difference between the Imports(as % of merchandise exports) of European Union in 2003 and the Imports(as % of merchandise exports) of Libya in 2010?
Offer a terse response. 1.17. What is the difference between the Imports(as % of merchandise exports) of European Union in 2003 and the Imports(as % of merchandise exports) of Portugal in 2010?
Make the answer very short. -0.09. What is the difference between the Imports(as % of merchandise exports) in Bulgaria in 2003 and the Imports(as % of merchandise exports) in Libya in 2010?
Your response must be concise. 3.85. What is the difference between the Imports(as % of merchandise exports) in Bulgaria in 2003 and the Imports(as % of merchandise exports) in Portugal in 2010?
Ensure brevity in your answer.  2.58. What is the difference between the Imports(as % of merchandise exports) in Libya in 2003 and the Imports(as % of merchandise exports) in Portugal in 2010?
Provide a succinct answer. -1.94. What is the difference between the Imports(as % of merchandise exports) of European Union in 2004 and the Imports(as % of merchandise exports) of Bulgaria in 2007?
Provide a short and direct response. -5.71. What is the difference between the Imports(as % of merchandise exports) in European Union in 2004 and the Imports(as % of merchandise exports) in Libya in 2007?
Give a very brief answer. 1.05. What is the difference between the Imports(as % of merchandise exports) of European Union in 2004 and the Imports(as % of merchandise exports) of Portugal in 2007?
Keep it short and to the point. -0.29. What is the difference between the Imports(as % of merchandise exports) of Bulgaria in 2004 and the Imports(as % of merchandise exports) of Libya in 2007?
Make the answer very short. 4.2. What is the difference between the Imports(as % of merchandise exports) in Bulgaria in 2004 and the Imports(as % of merchandise exports) in Portugal in 2007?
Provide a succinct answer. 2.85. What is the difference between the Imports(as % of merchandise exports) of Libya in 2004 and the Imports(as % of merchandise exports) of Portugal in 2007?
Ensure brevity in your answer.  -2.5. What is the difference between the Imports(as % of merchandise exports) of European Union in 2004 and the Imports(as % of merchandise exports) of Bulgaria in 2008?
Provide a short and direct response. -4.57. What is the difference between the Imports(as % of merchandise exports) in European Union in 2004 and the Imports(as % of merchandise exports) in Libya in 2008?
Your answer should be compact. 1.92. What is the difference between the Imports(as % of merchandise exports) of European Union in 2004 and the Imports(as % of merchandise exports) of Portugal in 2008?
Your answer should be very brief. 0.02. What is the difference between the Imports(as % of merchandise exports) of Bulgaria in 2004 and the Imports(as % of merchandise exports) of Libya in 2008?
Your answer should be compact. 5.07. What is the difference between the Imports(as % of merchandise exports) of Bulgaria in 2004 and the Imports(as % of merchandise exports) of Portugal in 2008?
Make the answer very short. 3.17. What is the difference between the Imports(as % of merchandise exports) in Libya in 2004 and the Imports(as % of merchandise exports) in Portugal in 2008?
Provide a short and direct response. -2.19. What is the difference between the Imports(as % of merchandise exports) in European Union in 2004 and the Imports(as % of merchandise exports) in Bulgaria in 2009?
Keep it short and to the point. -3.53. What is the difference between the Imports(as % of merchandise exports) in European Union in 2004 and the Imports(as % of merchandise exports) in Libya in 2009?
Offer a very short reply. 1.64. What is the difference between the Imports(as % of merchandise exports) of European Union in 2004 and the Imports(as % of merchandise exports) of Portugal in 2009?
Give a very brief answer. 0.92. What is the difference between the Imports(as % of merchandise exports) in Bulgaria in 2004 and the Imports(as % of merchandise exports) in Libya in 2009?
Provide a succinct answer. 4.79. What is the difference between the Imports(as % of merchandise exports) in Bulgaria in 2004 and the Imports(as % of merchandise exports) in Portugal in 2009?
Make the answer very short. 4.06. What is the difference between the Imports(as % of merchandise exports) in Libya in 2004 and the Imports(as % of merchandise exports) in Portugal in 2009?
Give a very brief answer. -1.29. What is the difference between the Imports(as % of merchandise exports) in European Union in 2004 and the Imports(as % of merchandise exports) in Bulgaria in 2010?
Provide a short and direct response. -5.86. What is the difference between the Imports(as % of merchandise exports) in European Union in 2004 and the Imports(as % of merchandise exports) in Libya in 2010?
Your answer should be very brief. 1.5. What is the difference between the Imports(as % of merchandise exports) in European Union in 2004 and the Imports(as % of merchandise exports) in Portugal in 2010?
Keep it short and to the point. 0.24. What is the difference between the Imports(as % of merchandise exports) in Bulgaria in 2004 and the Imports(as % of merchandise exports) in Libya in 2010?
Your answer should be very brief. 4.65. What is the difference between the Imports(as % of merchandise exports) in Bulgaria in 2004 and the Imports(as % of merchandise exports) in Portugal in 2010?
Make the answer very short. 3.38. What is the difference between the Imports(as % of merchandise exports) of Libya in 2004 and the Imports(as % of merchandise exports) of Portugal in 2010?
Your response must be concise. -1.97. What is the difference between the Imports(as % of merchandise exports) in European Union in 2007 and the Imports(as % of merchandise exports) in Bulgaria in 2008?
Offer a very short reply. -3.31. What is the difference between the Imports(as % of merchandise exports) in European Union in 2007 and the Imports(as % of merchandise exports) in Libya in 2008?
Keep it short and to the point. 3.18. What is the difference between the Imports(as % of merchandise exports) in European Union in 2007 and the Imports(as % of merchandise exports) in Portugal in 2008?
Keep it short and to the point. 1.28. What is the difference between the Imports(as % of merchandise exports) in Bulgaria in 2007 and the Imports(as % of merchandise exports) in Libya in 2008?
Your answer should be compact. 7.63. What is the difference between the Imports(as % of merchandise exports) in Bulgaria in 2007 and the Imports(as % of merchandise exports) in Portugal in 2008?
Offer a very short reply. 5.73. What is the difference between the Imports(as % of merchandise exports) of Libya in 2007 and the Imports(as % of merchandise exports) of Portugal in 2008?
Make the answer very short. -1.03. What is the difference between the Imports(as % of merchandise exports) of European Union in 2007 and the Imports(as % of merchandise exports) of Bulgaria in 2009?
Your answer should be compact. -2.27. What is the difference between the Imports(as % of merchandise exports) of European Union in 2007 and the Imports(as % of merchandise exports) of Libya in 2009?
Offer a terse response. 2.9. What is the difference between the Imports(as % of merchandise exports) of European Union in 2007 and the Imports(as % of merchandise exports) of Portugal in 2009?
Provide a succinct answer. 2.18. What is the difference between the Imports(as % of merchandise exports) of Bulgaria in 2007 and the Imports(as % of merchandise exports) of Libya in 2009?
Offer a terse response. 7.35. What is the difference between the Imports(as % of merchandise exports) in Bulgaria in 2007 and the Imports(as % of merchandise exports) in Portugal in 2009?
Your answer should be very brief. 6.62. What is the difference between the Imports(as % of merchandise exports) in Libya in 2007 and the Imports(as % of merchandise exports) in Portugal in 2009?
Ensure brevity in your answer.  -0.13. What is the difference between the Imports(as % of merchandise exports) of European Union in 2007 and the Imports(as % of merchandise exports) of Bulgaria in 2010?
Make the answer very short. -4.6. What is the difference between the Imports(as % of merchandise exports) of European Union in 2007 and the Imports(as % of merchandise exports) of Libya in 2010?
Your response must be concise. 2.76. What is the difference between the Imports(as % of merchandise exports) in European Union in 2007 and the Imports(as % of merchandise exports) in Portugal in 2010?
Offer a very short reply. 1.5. What is the difference between the Imports(as % of merchandise exports) in Bulgaria in 2007 and the Imports(as % of merchandise exports) in Libya in 2010?
Your answer should be compact. 7.21. What is the difference between the Imports(as % of merchandise exports) of Bulgaria in 2007 and the Imports(as % of merchandise exports) of Portugal in 2010?
Offer a very short reply. 5.94. What is the difference between the Imports(as % of merchandise exports) of Libya in 2007 and the Imports(as % of merchandise exports) of Portugal in 2010?
Provide a short and direct response. -0.81. What is the difference between the Imports(as % of merchandise exports) of European Union in 2008 and the Imports(as % of merchandise exports) of Bulgaria in 2009?
Offer a terse response. -2.8. What is the difference between the Imports(as % of merchandise exports) of European Union in 2008 and the Imports(as % of merchandise exports) of Libya in 2009?
Offer a very short reply. 2.36. What is the difference between the Imports(as % of merchandise exports) of European Union in 2008 and the Imports(as % of merchandise exports) of Portugal in 2009?
Offer a terse response. 1.64. What is the difference between the Imports(as % of merchandise exports) of Bulgaria in 2008 and the Imports(as % of merchandise exports) of Libya in 2009?
Your response must be concise. 6.21. What is the difference between the Imports(as % of merchandise exports) in Bulgaria in 2008 and the Imports(as % of merchandise exports) in Portugal in 2009?
Ensure brevity in your answer.  5.49. What is the difference between the Imports(as % of merchandise exports) of Libya in 2008 and the Imports(as % of merchandise exports) of Portugal in 2009?
Provide a short and direct response. -1. What is the difference between the Imports(as % of merchandise exports) of European Union in 2008 and the Imports(as % of merchandise exports) of Bulgaria in 2010?
Keep it short and to the point. -5.14. What is the difference between the Imports(as % of merchandise exports) of European Union in 2008 and the Imports(as % of merchandise exports) of Libya in 2010?
Provide a succinct answer. 2.22. What is the difference between the Imports(as % of merchandise exports) of European Union in 2008 and the Imports(as % of merchandise exports) of Portugal in 2010?
Provide a short and direct response. 0.96. What is the difference between the Imports(as % of merchandise exports) in Bulgaria in 2008 and the Imports(as % of merchandise exports) in Libya in 2010?
Your response must be concise. 6.07. What is the difference between the Imports(as % of merchandise exports) in Bulgaria in 2008 and the Imports(as % of merchandise exports) in Portugal in 2010?
Make the answer very short. 4.81. What is the difference between the Imports(as % of merchandise exports) in Libya in 2008 and the Imports(as % of merchandise exports) in Portugal in 2010?
Provide a succinct answer. -1.68. What is the difference between the Imports(as % of merchandise exports) in European Union in 2009 and the Imports(as % of merchandise exports) in Bulgaria in 2010?
Your answer should be compact. -6.07. What is the difference between the Imports(as % of merchandise exports) of European Union in 2009 and the Imports(as % of merchandise exports) of Libya in 2010?
Ensure brevity in your answer.  1.3. What is the difference between the Imports(as % of merchandise exports) in European Union in 2009 and the Imports(as % of merchandise exports) in Portugal in 2010?
Keep it short and to the point. 0.03. What is the difference between the Imports(as % of merchandise exports) of Bulgaria in 2009 and the Imports(as % of merchandise exports) of Libya in 2010?
Make the answer very short. 5.03. What is the difference between the Imports(as % of merchandise exports) in Bulgaria in 2009 and the Imports(as % of merchandise exports) in Portugal in 2010?
Ensure brevity in your answer.  3.76. What is the difference between the Imports(as % of merchandise exports) in Libya in 2009 and the Imports(as % of merchandise exports) in Portugal in 2010?
Your answer should be compact. -1.4. What is the average Imports(as % of merchandise exports) of European Union per year?
Your answer should be very brief. 3.48. What is the average Imports(as % of merchandise exports) of Bulgaria per year?
Your answer should be very brief. 7.02. What is the average Imports(as % of merchandise exports) of Libya per year?
Your response must be concise. 1.29. What is the average Imports(as % of merchandise exports) in Portugal per year?
Your answer should be very brief. 2.51. In the year 1997, what is the difference between the Imports(as % of merchandise exports) of European Union and Imports(as % of merchandise exports) of Bulgaria?
Provide a succinct answer. -2.4. In the year 1997, what is the difference between the Imports(as % of merchandise exports) in European Union and Imports(as % of merchandise exports) in Libya?
Your answer should be very brief. 2.77. In the year 1997, what is the difference between the Imports(as % of merchandise exports) in European Union and Imports(as % of merchandise exports) in Portugal?
Your response must be concise. 1.45. In the year 1997, what is the difference between the Imports(as % of merchandise exports) of Bulgaria and Imports(as % of merchandise exports) of Libya?
Give a very brief answer. 5.17. In the year 1997, what is the difference between the Imports(as % of merchandise exports) in Bulgaria and Imports(as % of merchandise exports) in Portugal?
Provide a succinct answer. 3.86. In the year 1997, what is the difference between the Imports(as % of merchandise exports) of Libya and Imports(as % of merchandise exports) of Portugal?
Offer a terse response. -1.32. In the year 1998, what is the difference between the Imports(as % of merchandise exports) in European Union and Imports(as % of merchandise exports) in Bulgaria?
Make the answer very short. -3.04. In the year 1998, what is the difference between the Imports(as % of merchandise exports) of European Union and Imports(as % of merchandise exports) of Libya?
Provide a succinct answer. 1.98. In the year 1998, what is the difference between the Imports(as % of merchandise exports) in European Union and Imports(as % of merchandise exports) in Portugal?
Give a very brief answer. 1.29. In the year 1998, what is the difference between the Imports(as % of merchandise exports) in Bulgaria and Imports(as % of merchandise exports) in Libya?
Offer a very short reply. 5.02. In the year 1998, what is the difference between the Imports(as % of merchandise exports) of Bulgaria and Imports(as % of merchandise exports) of Portugal?
Your answer should be very brief. 4.33. In the year 1998, what is the difference between the Imports(as % of merchandise exports) of Libya and Imports(as % of merchandise exports) of Portugal?
Your answer should be compact. -0.69. In the year 2003, what is the difference between the Imports(as % of merchandise exports) in European Union and Imports(as % of merchandise exports) in Bulgaria?
Provide a succinct answer. -2.67. In the year 2003, what is the difference between the Imports(as % of merchandise exports) of European Union and Imports(as % of merchandise exports) of Libya?
Offer a very short reply. 1.85. In the year 2003, what is the difference between the Imports(as % of merchandise exports) in European Union and Imports(as % of merchandise exports) in Portugal?
Offer a terse response. 0.49. In the year 2003, what is the difference between the Imports(as % of merchandise exports) of Bulgaria and Imports(as % of merchandise exports) of Libya?
Offer a very short reply. 4.52. In the year 2003, what is the difference between the Imports(as % of merchandise exports) in Bulgaria and Imports(as % of merchandise exports) in Portugal?
Your response must be concise. 3.17. In the year 2003, what is the difference between the Imports(as % of merchandise exports) of Libya and Imports(as % of merchandise exports) of Portugal?
Provide a short and direct response. -1.35. In the year 2004, what is the difference between the Imports(as % of merchandise exports) of European Union and Imports(as % of merchandise exports) of Bulgaria?
Provide a short and direct response. -3.15. In the year 2004, what is the difference between the Imports(as % of merchandise exports) of European Union and Imports(as % of merchandise exports) of Libya?
Provide a short and direct response. 2.21. In the year 2004, what is the difference between the Imports(as % of merchandise exports) in European Union and Imports(as % of merchandise exports) in Portugal?
Offer a very short reply. 1.07. In the year 2004, what is the difference between the Imports(as % of merchandise exports) of Bulgaria and Imports(as % of merchandise exports) of Libya?
Ensure brevity in your answer.  5.36. In the year 2004, what is the difference between the Imports(as % of merchandise exports) of Bulgaria and Imports(as % of merchandise exports) of Portugal?
Ensure brevity in your answer.  4.21. In the year 2004, what is the difference between the Imports(as % of merchandise exports) of Libya and Imports(as % of merchandise exports) of Portugal?
Ensure brevity in your answer.  -1.14. In the year 2007, what is the difference between the Imports(as % of merchandise exports) in European Union and Imports(as % of merchandise exports) in Bulgaria?
Offer a very short reply. -4.45. In the year 2007, what is the difference between the Imports(as % of merchandise exports) of European Union and Imports(as % of merchandise exports) of Libya?
Your response must be concise. 2.31. In the year 2007, what is the difference between the Imports(as % of merchandise exports) of European Union and Imports(as % of merchandise exports) of Portugal?
Offer a very short reply. 0.96. In the year 2007, what is the difference between the Imports(as % of merchandise exports) of Bulgaria and Imports(as % of merchandise exports) of Libya?
Your response must be concise. 6.76. In the year 2007, what is the difference between the Imports(as % of merchandise exports) of Bulgaria and Imports(as % of merchandise exports) of Portugal?
Your answer should be compact. 5.41. In the year 2007, what is the difference between the Imports(as % of merchandise exports) in Libya and Imports(as % of merchandise exports) in Portugal?
Ensure brevity in your answer.  -1.35. In the year 2008, what is the difference between the Imports(as % of merchandise exports) in European Union and Imports(as % of merchandise exports) in Bulgaria?
Keep it short and to the point. -3.85. In the year 2008, what is the difference between the Imports(as % of merchandise exports) in European Union and Imports(as % of merchandise exports) in Libya?
Ensure brevity in your answer.  2.64. In the year 2008, what is the difference between the Imports(as % of merchandise exports) in European Union and Imports(as % of merchandise exports) in Portugal?
Your answer should be very brief. 0.75. In the year 2008, what is the difference between the Imports(as % of merchandise exports) in Bulgaria and Imports(as % of merchandise exports) in Libya?
Provide a short and direct response. 6.49. In the year 2008, what is the difference between the Imports(as % of merchandise exports) in Bulgaria and Imports(as % of merchandise exports) in Portugal?
Provide a short and direct response. 4.59. In the year 2008, what is the difference between the Imports(as % of merchandise exports) in Libya and Imports(as % of merchandise exports) in Portugal?
Your response must be concise. -1.9. In the year 2009, what is the difference between the Imports(as % of merchandise exports) in European Union and Imports(as % of merchandise exports) in Bulgaria?
Keep it short and to the point. -3.73. In the year 2009, what is the difference between the Imports(as % of merchandise exports) in European Union and Imports(as % of merchandise exports) in Libya?
Offer a terse response. 1.43. In the year 2009, what is the difference between the Imports(as % of merchandise exports) of European Union and Imports(as % of merchandise exports) of Portugal?
Provide a short and direct response. 0.71. In the year 2009, what is the difference between the Imports(as % of merchandise exports) in Bulgaria and Imports(as % of merchandise exports) in Libya?
Your response must be concise. 5.17. In the year 2009, what is the difference between the Imports(as % of merchandise exports) of Bulgaria and Imports(as % of merchandise exports) of Portugal?
Keep it short and to the point. 4.44. In the year 2009, what is the difference between the Imports(as % of merchandise exports) of Libya and Imports(as % of merchandise exports) of Portugal?
Make the answer very short. -0.72. In the year 2010, what is the difference between the Imports(as % of merchandise exports) of European Union and Imports(as % of merchandise exports) of Bulgaria?
Provide a succinct answer. -5.04. In the year 2010, what is the difference between the Imports(as % of merchandise exports) of European Union and Imports(as % of merchandise exports) of Libya?
Provide a short and direct response. 2.33. In the year 2010, what is the difference between the Imports(as % of merchandise exports) of European Union and Imports(as % of merchandise exports) of Portugal?
Ensure brevity in your answer.  1.06. In the year 2010, what is the difference between the Imports(as % of merchandise exports) in Bulgaria and Imports(as % of merchandise exports) in Libya?
Your response must be concise. 7.36. In the year 2010, what is the difference between the Imports(as % of merchandise exports) of Bulgaria and Imports(as % of merchandise exports) of Portugal?
Offer a terse response. 6.1. In the year 2010, what is the difference between the Imports(as % of merchandise exports) in Libya and Imports(as % of merchandise exports) in Portugal?
Your answer should be compact. -1.26. What is the ratio of the Imports(as % of merchandise exports) of European Union in 1997 to that in 1998?
Give a very brief answer. 1.06. What is the ratio of the Imports(as % of merchandise exports) of Bulgaria in 1997 to that in 1998?
Your answer should be very brief. 0.93. What is the ratio of the Imports(as % of merchandise exports) of Libya in 1997 to that in 1998?
Give a very brief answer. 0.55. What is the ratio of the Imports(as % of merchandise exports) of Portugal in 1997 to that in 1998?
Your answer should be very brief. 1.01. What is the ratio of the Imports(as % of merchandise exports) in European Union in 1997 to that in 2003?
Offer a terse response. 1.25. What is the ratio of the Imports(as % of merchandise exports) of Bulgaria in 1997 to that in 2003?
Keep it short and to the point. 1.08. What is the ratio of the Imports(as % of merchandise exports) of Libya in 1997 to that in 2003?
Ensure brevity in your answer.  0.77. What is the ratio of the Imports(as % of merchandise exports) of Portugal in 1997 to that in 2003?
Offer a very short reply. 0.89. What is the ratio of the Imports(as % of merchandise exports) in European Union in 1997 to that in 2004?
Offer a very short reply. 1.12. What is the ratio of the Imports(as % of merchandise exports) of Bulgaria in 1997 to that in 2004?
Ensure brevity in your answer.  0.94. What is the ratio of the Imports(as % of merchandise exports) of Libya in 1997 to that in 2004?
Make the answer very short. 0.8. What is the ratio of the Imports(as % of merchandise exports) of Portugal in 1997 to that in 2004?
Provide a short and direct response. 1. What is the ratio of the Imports(as % of merchandise exports) of European Union in 1997 to that in 2007?
Make the answer very short. 0.8. What is the ratio of the Imports(as % of merchandise exports) in Bulgaria in 1997 to that in 2007?
Keep it short and to the point. 0.67. What is the ratio of the Imports(as % of merchandise exports) of Libya in 1997 to that in 2007?
Offer a very short reply. 0.35. What is the ratio of the Imports(as % of merchandise exports) in European Union in 1997 to that in 2008?
Make the answer very short. 0.91. What is the ratio of the Imports(as % of merchandise exports) of Bulgaria in 1997 to that in 2008?
Your answer should be compact. 0.77. What is the ratio of the Imports(as % of merchandise exports) in Libya in 1997 to that in 2008?
Offer a very short reply. 0.61. What is the ratio of the Imports(as % of merchandise exports) in Portugal in 1997 to that in 2008?
Make the answer very short. 0.66. What is the ratio of the Imports(as % of merchandise exports) in European Union in 1997 to that in 2009?
Offer a terse response. 1.2. What is the ratio of the Imports(as % of merchandise exports) in Bulgaria in 1997 to that in 2009?
Your answer should be compact. 0.89. What is the ratio of the Imports(as % of merchandise exports) of Libya in 1997 to that in 2009?
Your answer should be compact. 0.49. What is the ratio of the Imports(as % of merchandise exports) in Portugal in 1997 to that in 2009?
Provide a short and direct response. 0.93. What is the ratio of the Imports(as % of merchandise exports) of European Union in 1997 to that in 2010?
Ensure brevity in your answer.  0.89. What is the ratio of the Imports(as % of merchandise exports) in Bulgaria in 1997 to that in 2010?
Offer a very short reply. 0.66. What is the ratio of the Imports(as % of merchandise exports) in Libya in 1997 to that in 2010?
Your response must be concise. 0.45. What is the ratio of the Imports(as % of merchandise exports) in Portugal in 1997 to that in 2010?
Make the answer very short. 0.71. What is the ratio of the Imports(as % of merchandise exports) in European Union in 1998 to that in 2003?
Keep it short and to the point. 1.19. What is the ratio of the Imports(as % of merchandise exports) in Bulgaria in 1998 to that in 2003?
Your response must be concise. 1.16. What is the ratio of the Imports(as % of merchandise exports) of Libya in 1998 to that in 2003?
Your answer should be compact. 1.41. What is the ratio of the Imports(as % of merchandise exports) in Portugal in 1998 to that in 2003?
Your answer should be very brief. 0.88. What is the ratio of the Imports(as % of merchandise exports) of European Union in 1998 to that in 2004?
Provide a succinct answer. 1.06. What is the ratio of the Imports(as % of merchandise exports) in Bulgaria in 1998 to that in 2004?
Your answer should be compact. 1.01. What is the ratio of the Imports(as % of merchandise exports) of Libya in 1998 to that in 2004?
Provide a succinct answer. 1.46. What is the ratio of the Imports(as % of merchandise exports) of Portugal in 1998 to that in 2004?
Make the answer very short. 0.98. What is the ratio of the Imports(as % of merchandise exports) of European Union in 1998 to that in 2007?
Your response must be concise. 0.76. What is the ratio of the Imports(as % of merchandise exports) of Bulgaria in 1998 to that in 2007?
Your response must be concise. 0.72. What is the ratio of the Imports(as % of merchandise exports) of Libya in 1998 to that in 2007?
Provide a short and direct response. 0.65. What is the ratio of the Imports(as % of merchandise exports) of Portugal in 1998 to that in 2007?
Your response must be concise. 0.59. What is the ratio of the Imports(as % of merchandise exports) in European Union in 1998 to that in 2008?
Your answer should be compact. 0.86. What is the ratio of the Imports(as % of merchandise exports) of Bulgaria in 1998 to that in 2008?
Offer a terse response. 0.83. What is the ratio of the Imports(as % of merchandise exports) of Libya in 1998 to that in 2008?
Offer a very short reply. 1.11. What is the ratio of the Imports(as % of merchandise exports) in Portugal in 1998 to that in 2008?
Provide a short and direct response. 0.65. What is the ratio of the Imports(as % of merchandise exports) in European Union in 1998 to that in 2009?
Give a very brief answer. 1.14. What is the ratio of the Imports(as % of merchandise exports) of Bulgaria in 1998 to that in 2009?
Offer a very short reply. 0.96. What is the ratio of the Imports(as % of merchandise exports) of Libya in 1998 to that in 2009?
Your response must be concise. 0.9. What is the ratio of the Imports(as % of merchandise exports) in Portugal in 1998 to that in 2009?
Keep it short and to the point. 0.92. What is the ratio of the Imports(as % of merchandise exports) in European Union in 1998 to that in 2010?
Ensure brevity in your answer.  0.84. What is the ratio of the Imports(as % of merchandise exports) in Bulgaria in 1998 to that in 2010?
Offer a terse response. 0.71. What is the ratio of the Imports(as % of merchandise exports) of Libya in 1998 to that in 2010?
Your answer should be compact. 0.82. What is the ratio of the Imports(as % of merchandise exports) of Portugal in 1998 to that in 2010?
Provide a succinct answer. 0.7. What is the ratio of the Imports(as % of merchandise exports) of European Union in 2003 to that in 2004?
Provide a short and direct response. 0.89. What is the ratio of the Imports(as % of merchandise exports) of Bulgaria in 2003 to that in 2004?
Provide a succinct answer. 0.87. What is the ratio of the Imports(as % of merchandise exports) of Libya in 2003 to that in 2004?
Offer a very short reply. 1.03. What is the ratio of the Imports(as % of merchandise exports) in Portugal in 2003 to that in 2004?
Offer a terse response. 1.12. What is the ratio of the Imports(as % of merchandise exports) in European Union in 2003 to that in 2007?
Ensure brevity in your answer.  0.64. What is the ratio of the Imports(as % of merchandise exports) in Bulgaria in 2003 to that in 2007?
Your response must be concise. 0.62. What is the ratio of the Imports(as % of merchandise exports) of Libya in 2003 to that in 2007?
Offer a very short reply. 0.46. What is the ratio of the Imports(as % of merchandise exports) of Portugal in 2003 to that in 2007?
Provide a succinct answer. 0.67. What is the ratio of the Imports(as % of merchandise exports) in European Union in 2003 to that in 2008?
Keep it short and to the point. 0.73. What is the ratio of the Imports(as % of merchandise exports) in Bulgaria in 2003 to that in 2008?
Ensure brevity in your answer.  0.71. What is the ratio of the Imports(as % of merchandise exports) in Libya in 2003 to that in 2008?
Give a very brief answer. 0.79. What is the ratio of the Imports(as % of merchandise exports) of Portugal in 2003 to that in 2008?
Make the answer very short. 0.74. What is the ratio of the Imports(as % of merchandise exports) in European Union in 2003 to that in 2009?
Give a very brief answer. 0.96. What is the ratio of the Imports(as % of merchandise exports) of Bulgaria in 2003 to that in 2009?
Make the answer very short. 0.82. What is the ratio of the Imports(as % of merchandise exports) of Libya in 2003 to that in 2009?
Your response must be concise. 0.64. What is the ratio of the Imports(as % of merchandise exports) of Portugal in 2003 to that in 2009?
Your answer should be very brief. 1.04. What is the ratio of the Imports(as % of merchandise exports) of European Union in 2003 to that in 2010?
Keep it short and to the point. 0.71. What is the ratio of the Imports(as % of merchandise exports) in Bulgaria in 2003 to that in 2010?
Make the answer very short. 0.61. What is the ratio of the Imports(as % of merchandise exports) of Libya in 2003 to that in 2010?
Your answer should be compact. 0.58. What is the ratio of the Imports(as % of merchandise exports) of Portugal in 2003 to that in 2010?
Provide a succinct answer. 0.8. What is the ratio of the Imports(as % of merchandise exports) of European Union in 2004 to that in 2007?
Offer a terse response. 0.71. What is the ratio of the Imports(as % of merchandise exports) in Bulgaria in 2004 to that in 2007?
Give a very brief answer. 0.71. What is the ratio of the Imports(as % of merchandise exports) of Libya in 2004 to that in 2007?
Offer a terse response. 0.44. What is the ratio of the Imports(as % of merchandise exports) in Portugal in 2004 to that in 2007?
Make the answer very short. 0.6. What is the ratio of the Imports(as % of merchandise exports) of European Union in 2004 to that in 2008?
Your answer should be very brief. 0.81. What is the ratio of the Imports(as % of merchandise exports) in Bulgaria in 2004 to that in 2008?
Your answer should be compact. 0.82. What is the ratio of the Imports(as % of merchandise exports) in Libya in 2004 to that in 2008?
Provide a succinct answer. 0.76. What is the ratio of the Imports(as % of merchandise exports) in Portugal in 2004 to that in 2008?
Provide a succinct answer. 0.66. What is the ratio of the Imports(as % of merchandise exports) in European Union in 2004 to that in 2009?
Your answer should be compact. 1.07. What is the ratio of the Imports(as % of merchandise exports) of Bulgaria in 2004 to that in 2009?
Give a very brief answer. 0.94. What is the ratio of the Imports(as % of merchandise exports) of Libya in 2004 to that in 2009?
Provide a short and direct response. 0.62. What is the ratio of the Imports(as % of merchandise exports) in Portugal in 2004 to that in 2009?
Offer a very short reply. 0.93. What is the ratio of the Imports(as % of merchandise exports) in European Union in 2004 to that in 2010?
Provide a short and direct response. 0.79. What is the ratio of the Imports(as % of merchandise exports) of Bulgaria in 2004 to that in 2010?
Offer a terse response. 0.7. What is the ratio of the Imports(as % of merchandise exports) of Libya in 2004 to that in 2010?
Offer a very short reply. 0.57. What is the ratio of the Imports(as % of merchandise exports) of Portugal in 2004 to that in 2010?
Your answer should be very brief. 0.71. What is the ratio of the Imports(as % of merchandise exports) of European Union in 2007 to that in 2008?
Your response must be concise. 1.14. What is the ratio of the Imports(as % of merchandise exports) in Bulgaria in 2007 to that in 2008?
Offer a terse response. 1.15. What is the ratio of the Imports(as % of merchandise exports) of Libya in 2007 to that in 2008?
Your answer should be compact. 1.72. What is the ratio of the Imports(as % of merchandise exports) in Portugal in 2007 to that in 2008?
Your answer should be compact. 1.1. What is the ratio of the Imports(as % of merchandise exports) in European Union in 2007 to that in 2009?
Provide a short and direct response. 1.5. What is the ratio of the Imports(as % of merchandise exports) of Bulgaria in 2007 to that in 2009?
Make the answer very short. 1.33. What is the ratio of the Imports(as % of merchandise exports) of Libya in 2007 to that in 2009?
Provide a short and direct response. 1.4. What is the ratio of the Imports(as % of merchandise exports) in Portugal in 2007 to that in 2009?
Offer a terse response. 1.55. What is the ratio of the Imports(as % of merchandise exports) of European Union in 2007 to that in 2010?
Provide a short and direct response. 1.11. What is the ratio of the Imports(as % of merchandise exports) in Bulgaria in 2007 to that in 2010?
Give a very brief answer. 0.98. What is the ratio of the Imports(as % of merchandise exports) of Libya in 2007 to that in 2010?
Give a very brief answer. 1.28. What is the ratio of the Imports(as % of merchandise exports) of Portugal in 2007 to that in 2010?
Offer a terse response. 1.18. What is the ratio of the Imports(as % of merchandise exports) of European Union in 2008 to that in 2009?
Keep it short and to the point. 1.32. What is the ratio of the Imports(as % of merchandise exports) in Bulgaria in 2008 to that in 2009?
Your answer should be compact. 1.16. What is the ratio of the Imports(as % of merchandise exports) of Libya in 2008 to that in 2009?
Offer a terse response. 0.81. What is the ratio of the Imports(as % of merchandise exports) in Portugal in 2008 to that in 2009?
Your answer should be compact. 1.4. What is the ratio of the Imports(as % of merchandise exports) of European Union in 2008 to that in 2010?
Your response must be concise. 0.97. What is the ratio of the Imports(as % of merchandise exports) in Bulgaria in 2008 to that in 2010?
Make the answer very short. 0.86. What is the ratio of the Imports(as % of merchandise exports) of Libya in 2008 to that in 2010?
Ensure brevity in your answer.  0.74. What is the ratio of the Imports(as % of merchandise exports) in Portugal in 2008 to that in 2010?
Your answer should be very brief. 1.07. What is the ratio of the Imports(as % of merchandise exports) in European Union in 2009 to that in 2010?
Provide a succinct answer. 0.74. What is the ratio of the Imports(as % of merchandise exports) in Bulgaria in 2009 to that in 2010?
Provide a succinct answer. 0.74. What is the ratio of the Imports(as % of merchandise exports) in Libya in 2009 to that in 2010?
Offer a very short reply. 0.91. What is the ratio of the Imports(as % of merchandise exports) in Portugal in 2009 to that in 2010?
Your answer should be very brief. 0.76. What is the difference between the highest and the second highest Imports(as % of merchandise exports) in European Union?
Give a very brief answer. 0.43. What is the difference between the highest and the second highest Imports(as % of merchandise exports) in Bulgaria?
Your answer should be compact. 0.16. What is the difference between the highest and the second highest Imports(as % of merchandise exports) in Libya?
Make the answer very short. 0.45. What is the difference between the highest and the second highest Imports(as % of merchandise exports) in Portugal?
Give a very brief answer. 0.32. What is the difference between the highest and the lowest Imports(as % of merchandise exports) of European Union?
Offer a terse response. 1.59. What is the difference between the highest and the lowest Imports(as % of merchandise exports) of Bulgaria?
Keep it short and to the point. 3.52. What is the difference between the highest and the lowest Imports(as % of merchandise exports) of Libya?
Your answer should be compact. 1.34. What is the difference between the highest and the lowest Imports(as % of merchandise exports) in Portugal?
Provide a short and direct response. 1.39. 